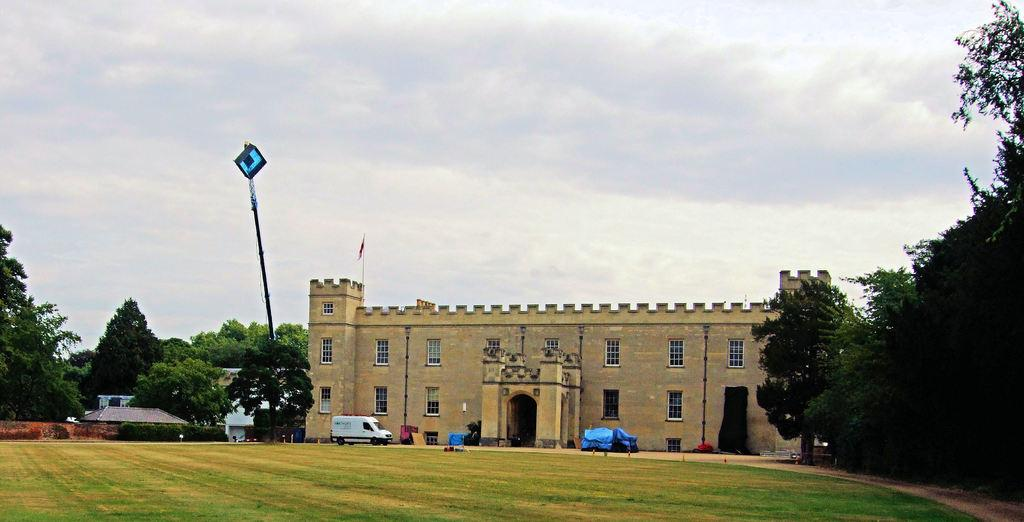What is the main subject in the image? There is a vehicle in the image. What else can be seen in the image besides the vehicle? There is a building in the image. What is on top of the building? The building has a flag on top. What type of vegetation is present on either side of the building? There are trees on either side of the building. What type of pan is being used to drive the vehicle in the image? There is no pan present in the image, and the vehicle is not being driven by a pan. 